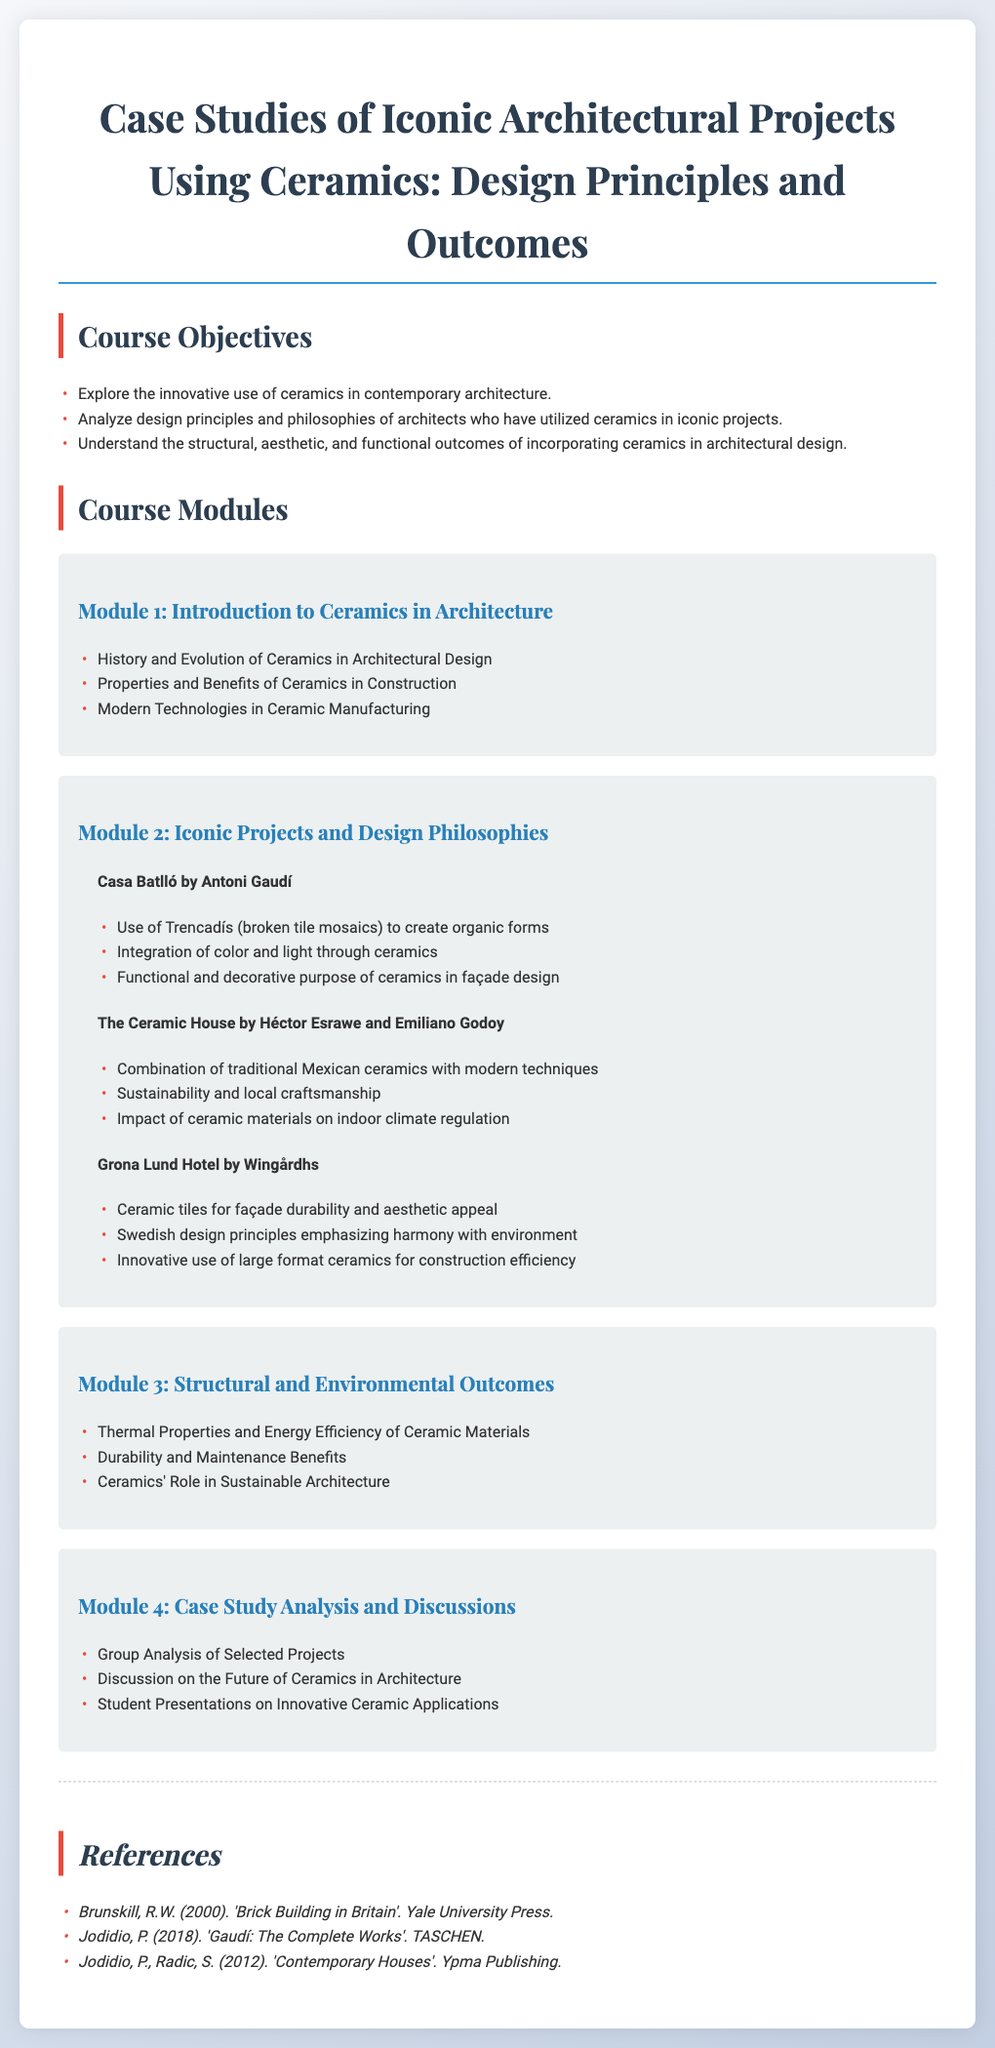What are the course objectives? The course objectives are outlined at the beginning of the syllabus, highlighting exploration, analysis, and understanding of ceramics in architecture.
Answer: Explore the innovative use of ceramics in contemporary architecture, Analyze design principles and philosophies of architects who have utilized ceramics in iconic projects, Understand the structural, aesthetic, and functional outcomes of incorporating ceramics in architectural design Who designed Casa Batlló? The syllabus provides the name of the architect associated with Casa Batlló in Module 2.
Answer: Antoni Gaudí What type of ceramics are used in The Ceramic House? The course discusses the combination of specific ceramics in Module 2.
Answer: Traditional Mexican ceramics What is emphasized in the design principles of Grona Lund Hotel? The syllabus mentions specific design principles related to Swedish architecture in the description of Grona Lund Hotel.
Answer: Harmony with environment How many modules are in the course? The syllabus lists the total number of modules within the course structure.
Answer: Four What is a focus of Module 3? The module outlines specific themes related to ceramics in architecture.
Answer: Structural and Environmental Outcomes What is one objective of the Case Study Analysis module? The syllabus indicates goals related to student activities in the last module.
Answer: Group Analysis of Selected Projects 